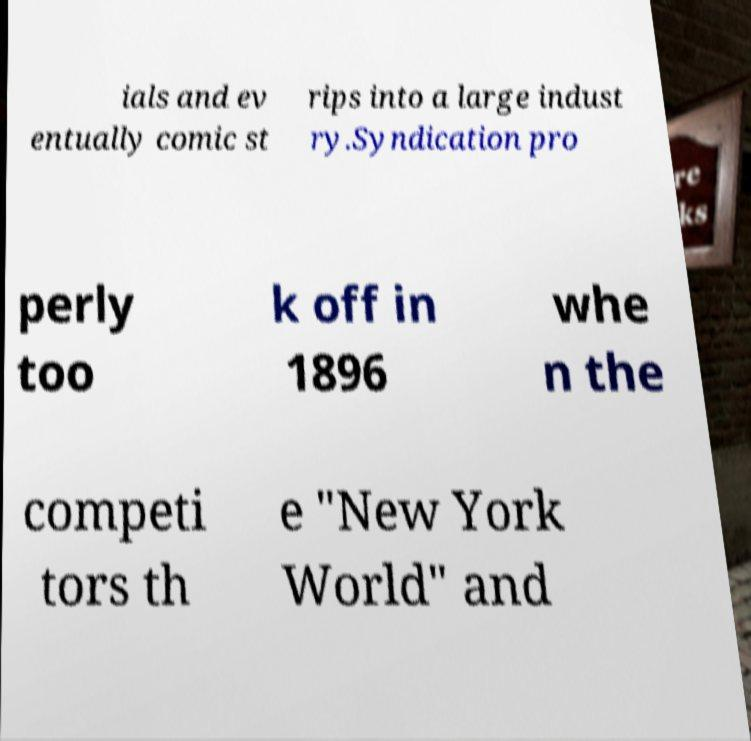Please read and relay the text visible in this image. What does it say? ials and ev entually comic st rips into a large indust ry.Syndication pro perly too k off in 1896 whe n the competi tors th e "New York World" and 